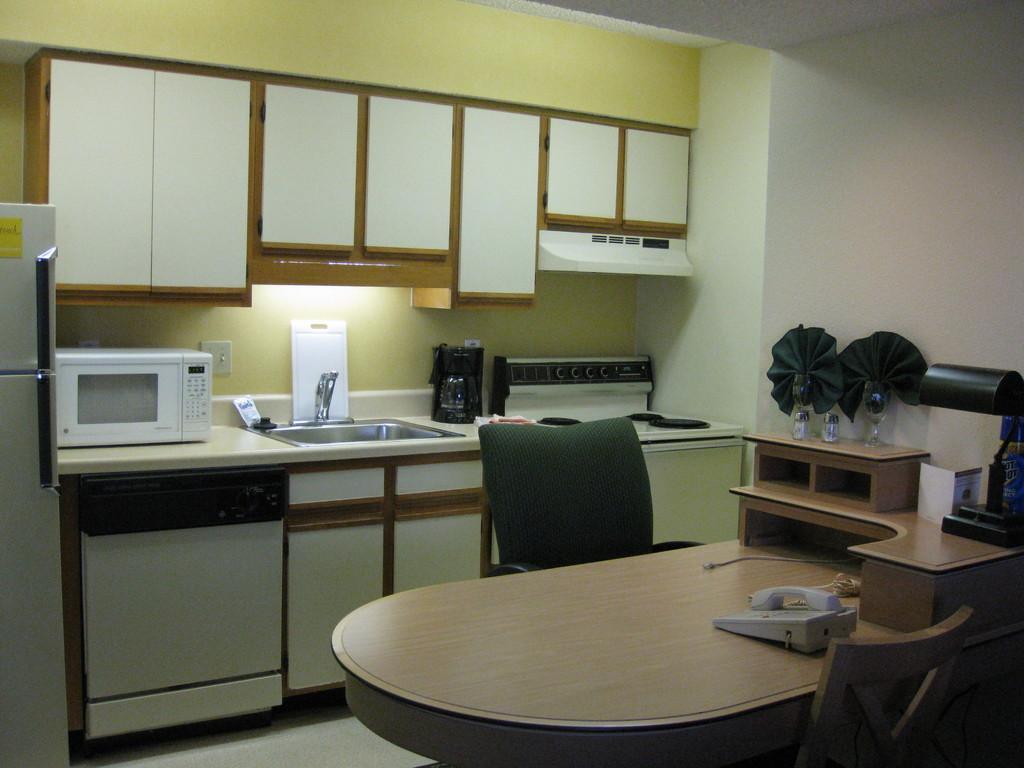Please provide a concise description of this image. This picture is about interior of the room, in this we can find a telephone, bottles on the table and we can find couple of chairs, gas, tap, oven and a fridge in the room. 